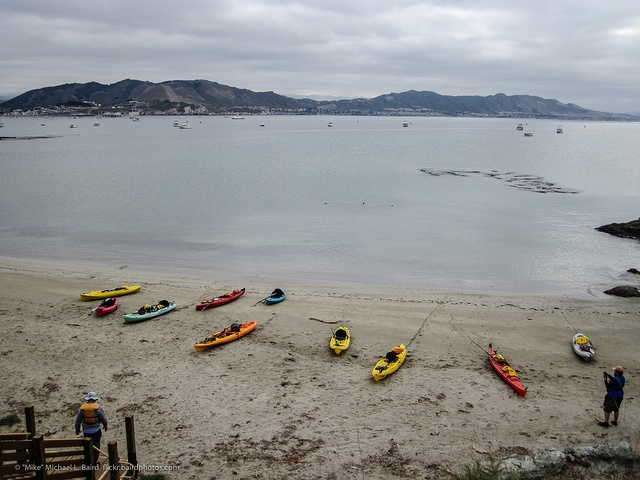Describe the objects in this image and their specific colors. I can see boat in darkgray and gray tones, people in darkgray, black, gray, maroon, and navy tones, people in darkgray, black, gray, navy, and maroon tones, boat in darkgray, black, brown, maroon, and orange tones, and boat in darkgray, black, gold, and olive tones in this image. 